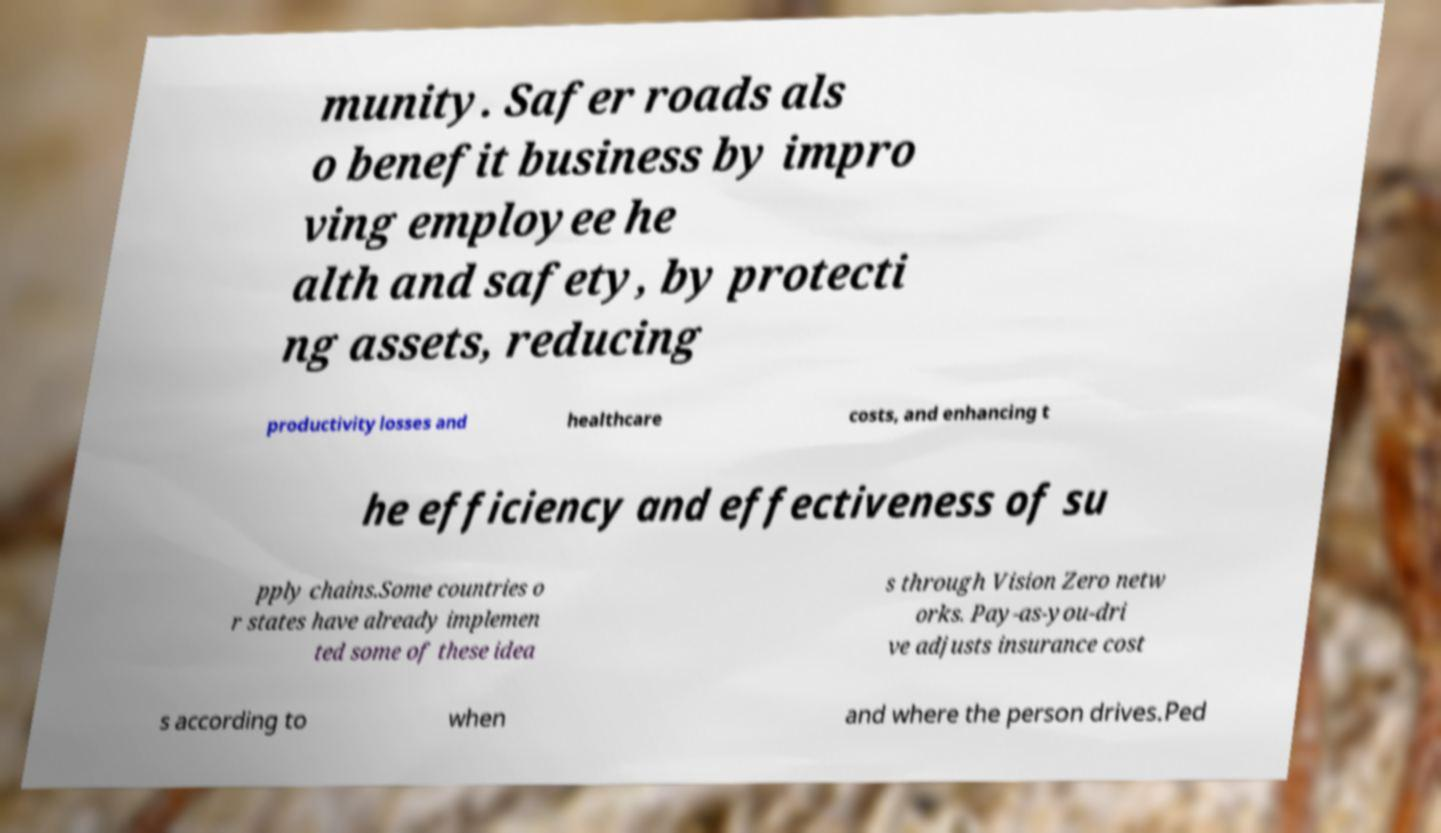Please read and relay the text visible in this image. What does it say? munity. Safer roads als o benefit business by impro ving employee he alth and safety, by protecti ng assets, reducing productivity losses and healthcare costs, and enhancing t he efficiency and effectiveness of su pply chains.Some countries o r states have already implemen ted some of these idea s through Vision Zero netw orks. Pay-as-you-dri ve adjusts insurance cost s according to when and where the person drives.Ped 